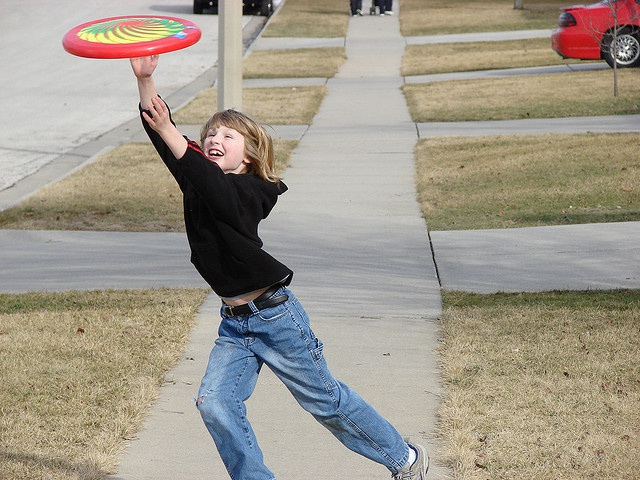Describe the objects in this image and their specific colors. I can see people in darkgray, black, and gray tones, car in darkgray, brown, black, and gray tones, frisbee in darkgray, salmon, khaki, red, and lightpink tones, car in darkgray, black, and gray tones, and people in darkgray, black, and gray tones in this image. 